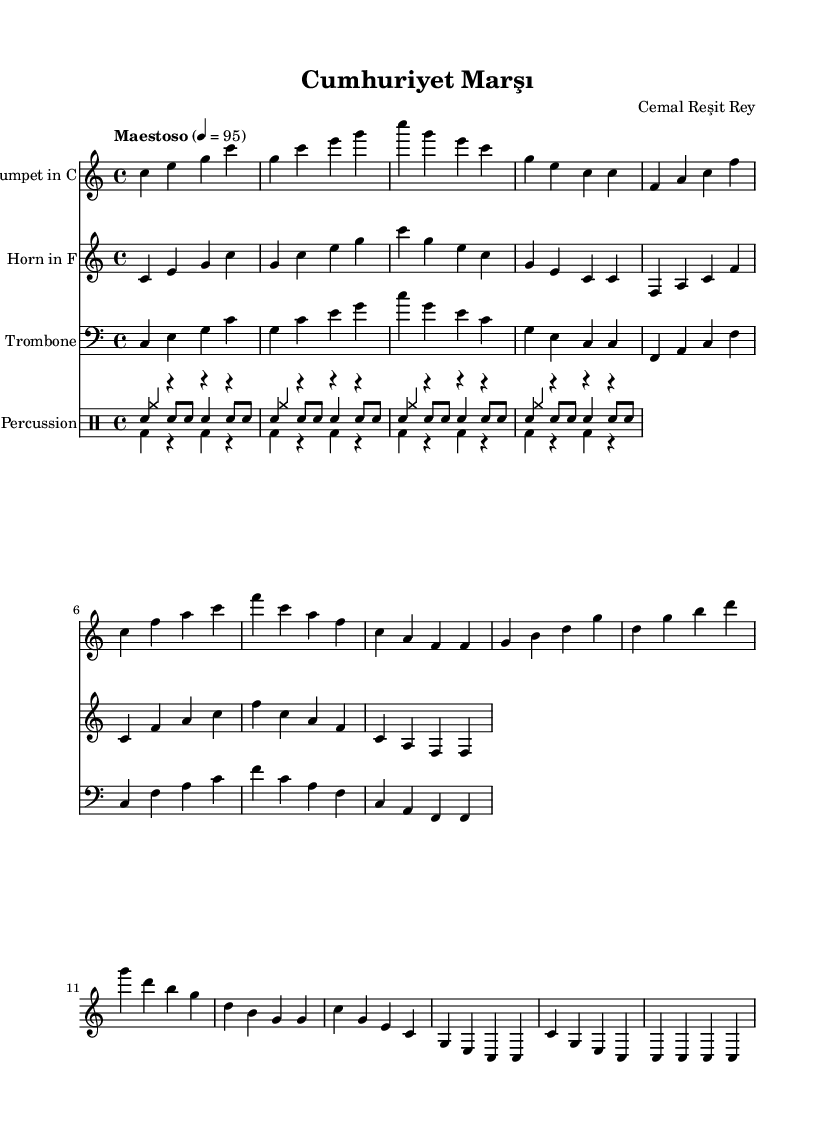What is the key signature of this music? The key signature is indicated at the beginning of the score, showing no sharps or flats. This confirms that the key is C major.
Answer: C major What is the time signature of the piece? The time signature is located on the staff at the beginning of the piece, shown as 4/4, which means there are four beats in each measure.
Answer: 4/4 What is the tempo marking for this piece? The tempo marking appears above the staff, indicated as "Maestoso" with a metronome marking of 4 = 95. This means the piece is to be played at a slow, dignified pace.
Answer: Maestoso How many measures are in the first section of the trumpet part? By counting the number of distinct groupings of notes separated by vertical lines, the first section contains 8 measures.
Answer: 8 Which instruments are included in the score? By examining the score layout, we see the parts labeled for Trumpet in C, Horn in F, Trombone, and Percussion. This indicates the instruments used in this piece.
Answer: Trumpet, Horn, Trombone, Percussion What is the last note of the trumpet part? The final note in the trumpet line is represented at the end of the part, which is a C note, identified as the highest note on the staff in the last measure.
Answer: C What is the instrumentation of the percussion section? The percussion section is made up of three voices: snare drum, bass drum, and cymbals, as indicated by the labeled parts in the score.
Answer: Snare, Bass, Cymbals 